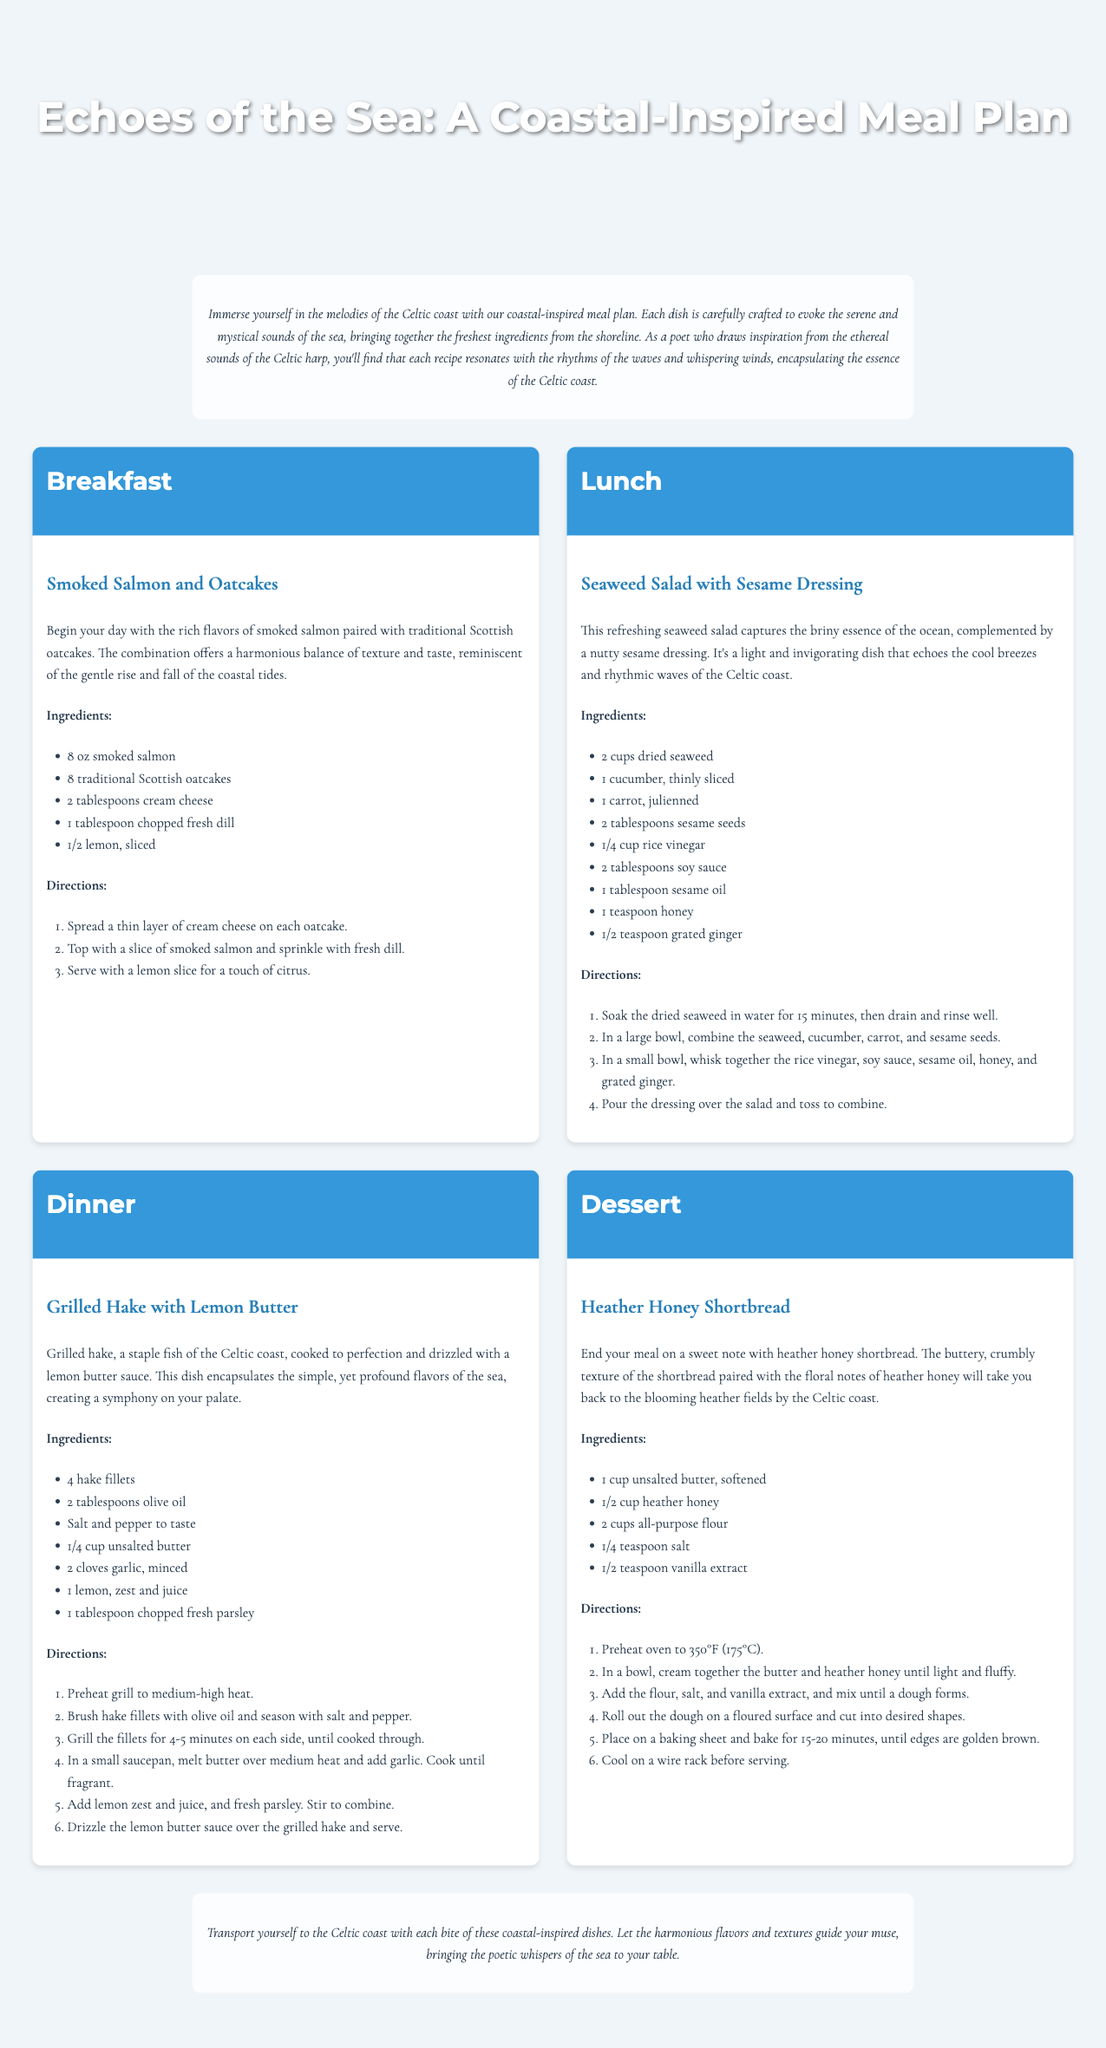What is the title of the meal plan? The title is stated in the header section of the document.
Answer: Echoes of the Sea: A Coastal-Inspired Meal Plan How many ingredients are listed for the Smoked Salmon and Oatcakes? The ingredients are listed in a bulleted format under the recipe, and there are five items.
Answer: 5 What is the main ingredient in the Seaweed Salad? The main ingredient is mentioned at the beginning of the recipe description.
Answer: Dried seaweed What is the cooking time for the Grilled Hake? The cooking time is specified in the directions of the recipe for how long to grill the fillets.
Answer: 4-5 minutes on each side What type of honey is used in the Heather Honey Shortbread? The type of honey is mentioned in the ingredient list of the dessert recipe.
Answer: Heather honey Which meal features a citrus ingredient? The meal description provides clues about the ingredients included; one mentions lemon, indicating the dish that includes it.
Answer: Breakfast How many meals are included in the meal plan? The meal plan lists four distinct meal sections, each labeled appropriately.
Answer: 4 What is the method of preparation for the Seaweed Salad? The method for preparing the salad is described in a series of steps under the recipe.
Answer: Toss to combine What is the cooking temperature for the shortbread? The temperature is specified in the directions at the beginning of the dessert recipe.
Answer: 350°F (175°C) 